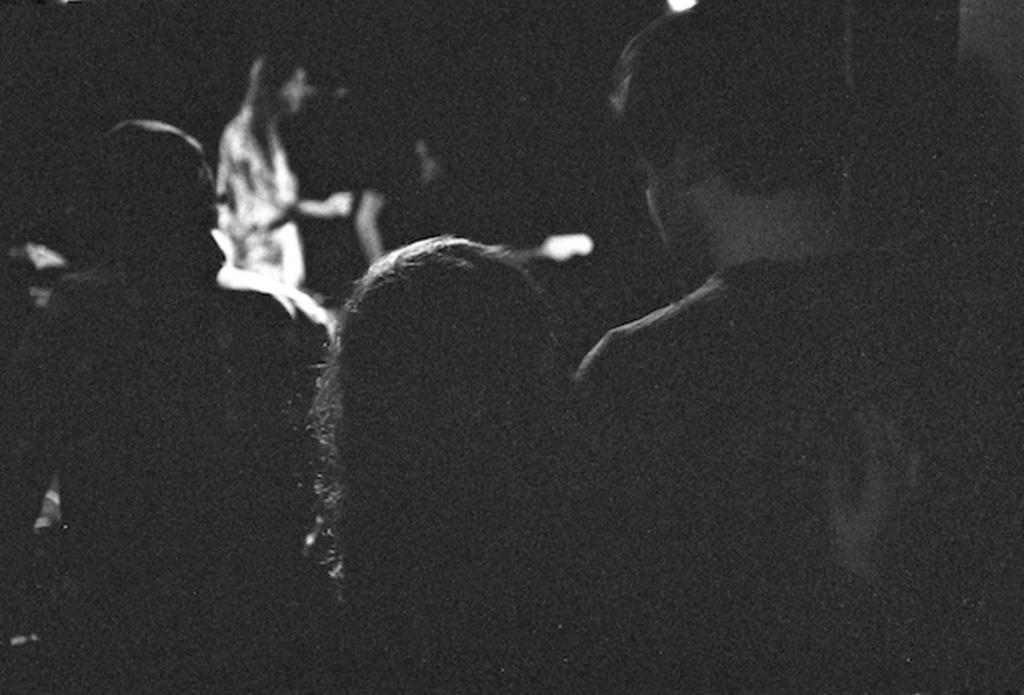What is the setting of the image? The image was likely taken indoors. What can be seen in the foreground of the image? There is a group of persons in the foreground of the image. How would you describe the background of the image? The background of the image is dark. Can you identify any other persons in the image besides the group in the foreground? Yes, there appears to be a person standing in the background. What type of cabbage is being used as a hat by the person in the background? There is no cabbage present in the image, and no one is wearing a cabbage as a hat. How many times does the person in the background roll their eyes during the scene? There is no indication of eye-rolling in the image, so it cannot be determined. 